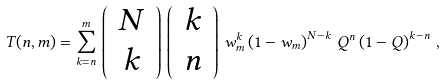<formula> <loc_0><loc_0><loc_500><loc_500>T ( n , m ) = \sum _ { k = n } ^ { m } \, \left ( \, \begin{array} { c } N \\ k \end{array} \, \right ) \, \left ( \, \begin{array} { c } k \\ n \end{array} \, \right ) \, w _ { m } ^ { k } \left ( 1 - w _ { m } \right ) ^ { N - k } \, Q ^ { n } \left ( 1 - Q \right ) ^ { k - n } \, ,</formula> 